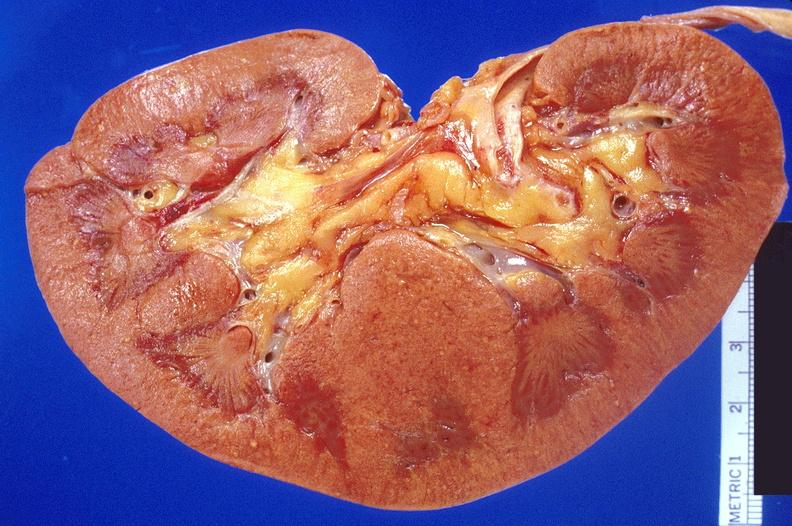does choanal patency show kidney, candida abscesses?
Answer the question using a single word or phrase. No 